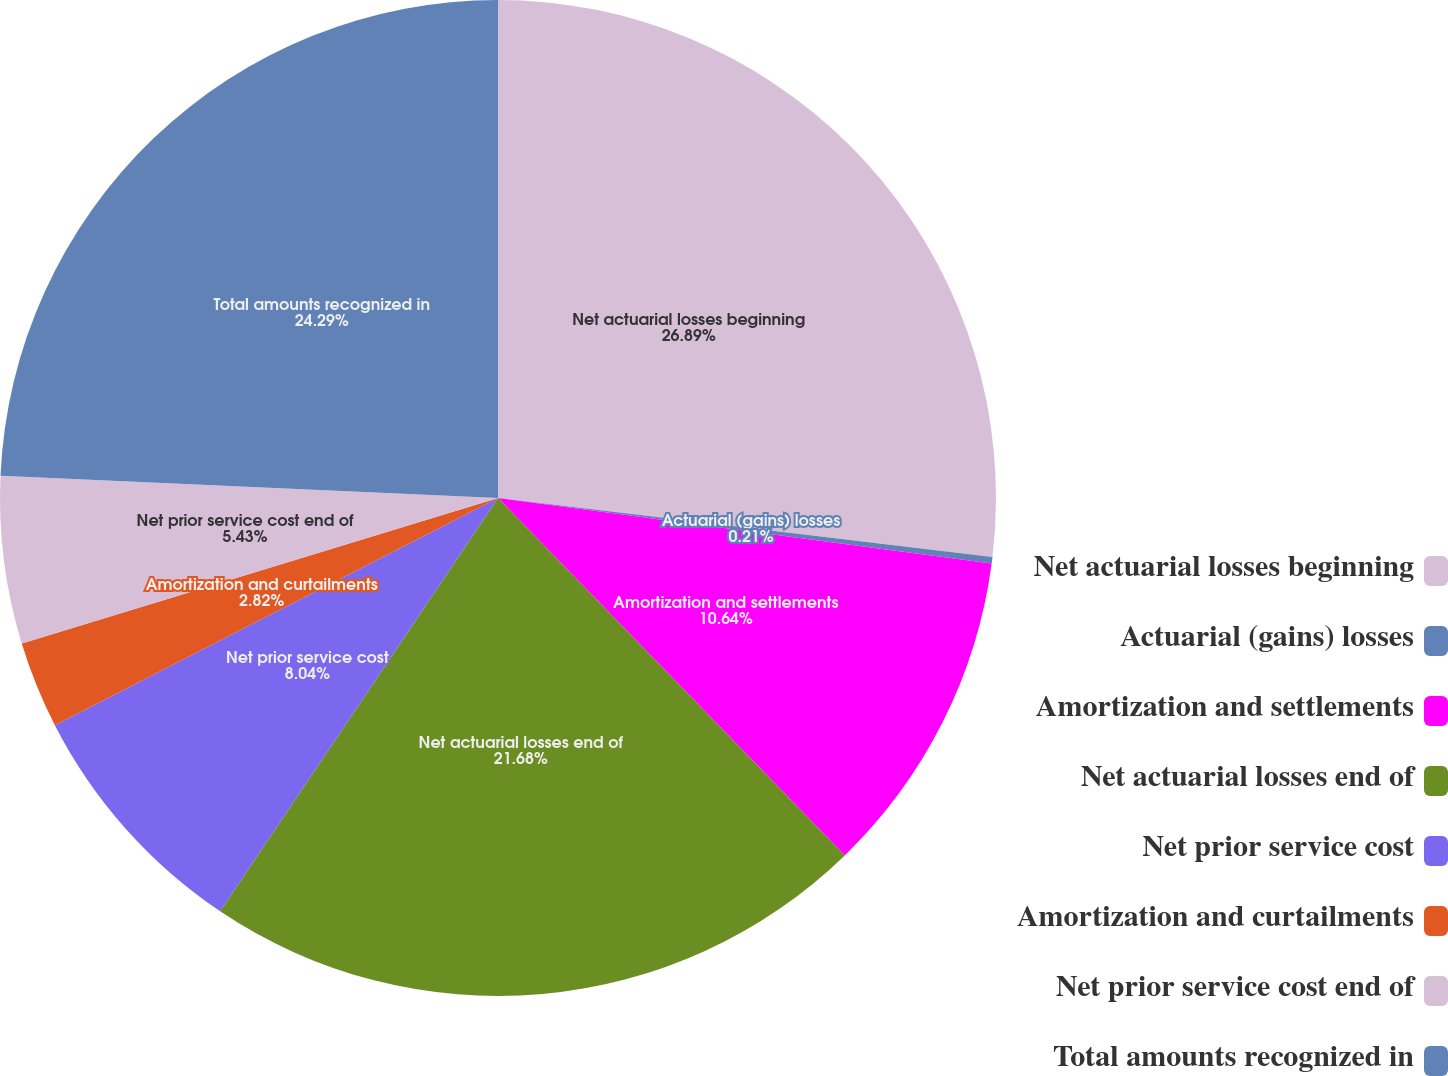<chart> <loc_0><loc_0><loc_500><loc_500><pie_chart><fcel>Net actuarial losses beginning<fcel>Actuarial (gains) losses<fcel>Amortization and settlements<fcel>Net actuarial losses end of<fcel>Net prior service cost<fcel>Amortization and curtailments<fcel>Net prior service cost end of<fcel>Total amounts recognized in<nl><fcel>26.89%<fcel>0.21%<fcel>10.64%<fcel>21.68%<fcel>8.04%<fcel>2.82%<fcel>5.43%<fcel>24.29%<nl></chart> 